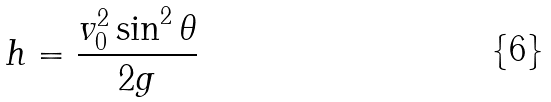<formula> <loc_0><loc_0><loc_500><loc_500>h = \frac { v _ { 0 } ^ { 2 } \sin ^ { 2 } \theta } { 2 g }</formula> 